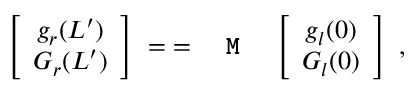Convert formula to latex. <formula><loc_0><loc_0><loc_500><loc_500>\left [ \begin{array} { c c } { g _ { r } ( L ^ { \prime } ) } \\ { G _ { r } ( L ^ { \prime } ) } \end{array} \right ] \, = \, = M \, \left [ \begin{array} { c c } { g _ { l } ( 0 ) } \\ { G _ { l } ( 0 ) } \end{array} \right ] \, ,</formula> 